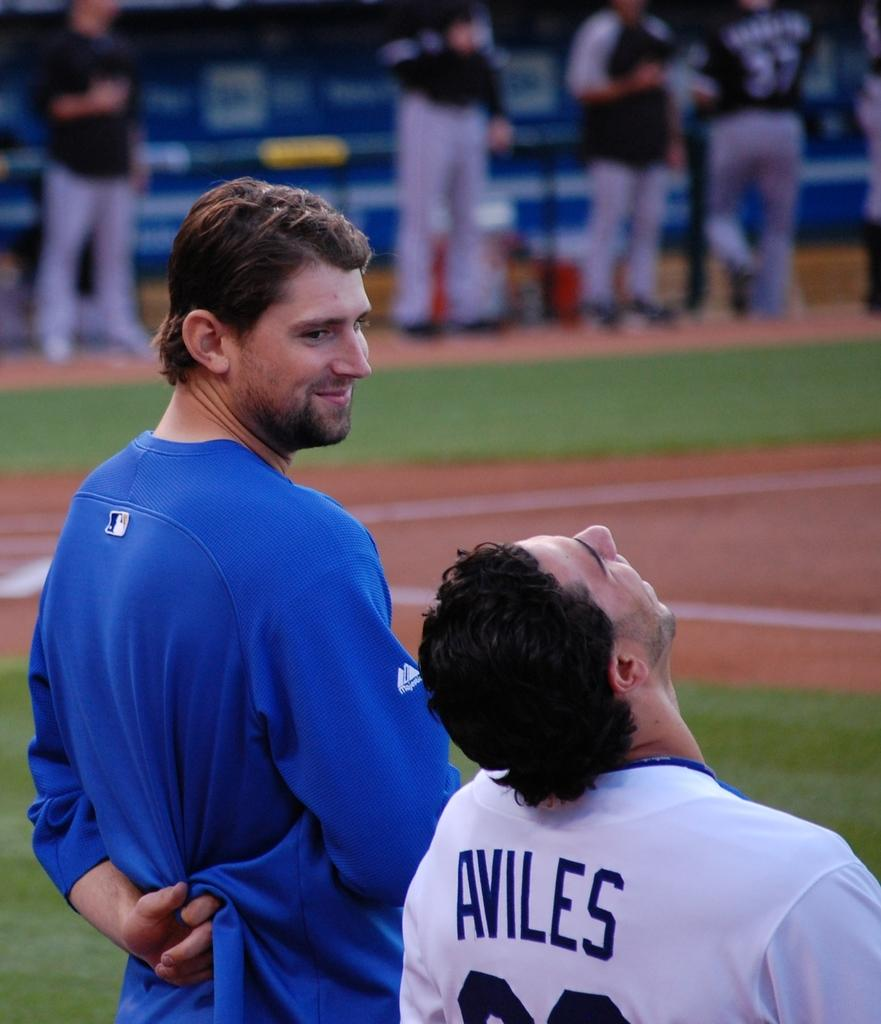<image>
Offer a succinct explanation of the picture presented. A baseball player named Aviles looking up at the sky. 